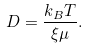<formula> <loc_0><loc_0><loc_500><loc_500>D = \frac { k _ { B } T } { \xi \mu } .</formula> 